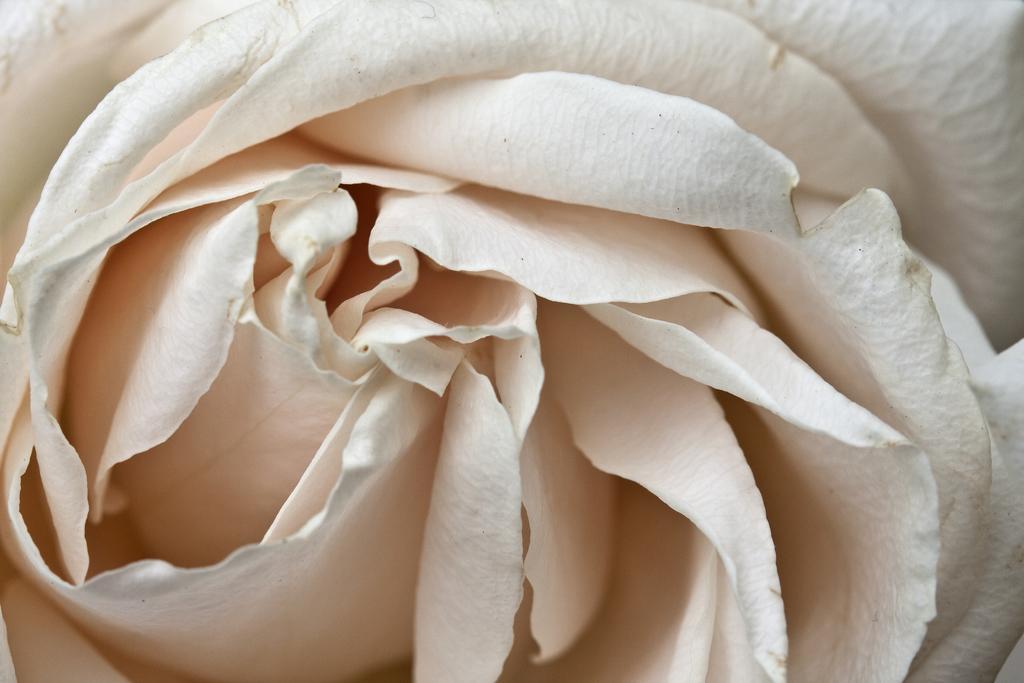How would you summarize this image in a sentence or two? In the picture there is a flower present. 